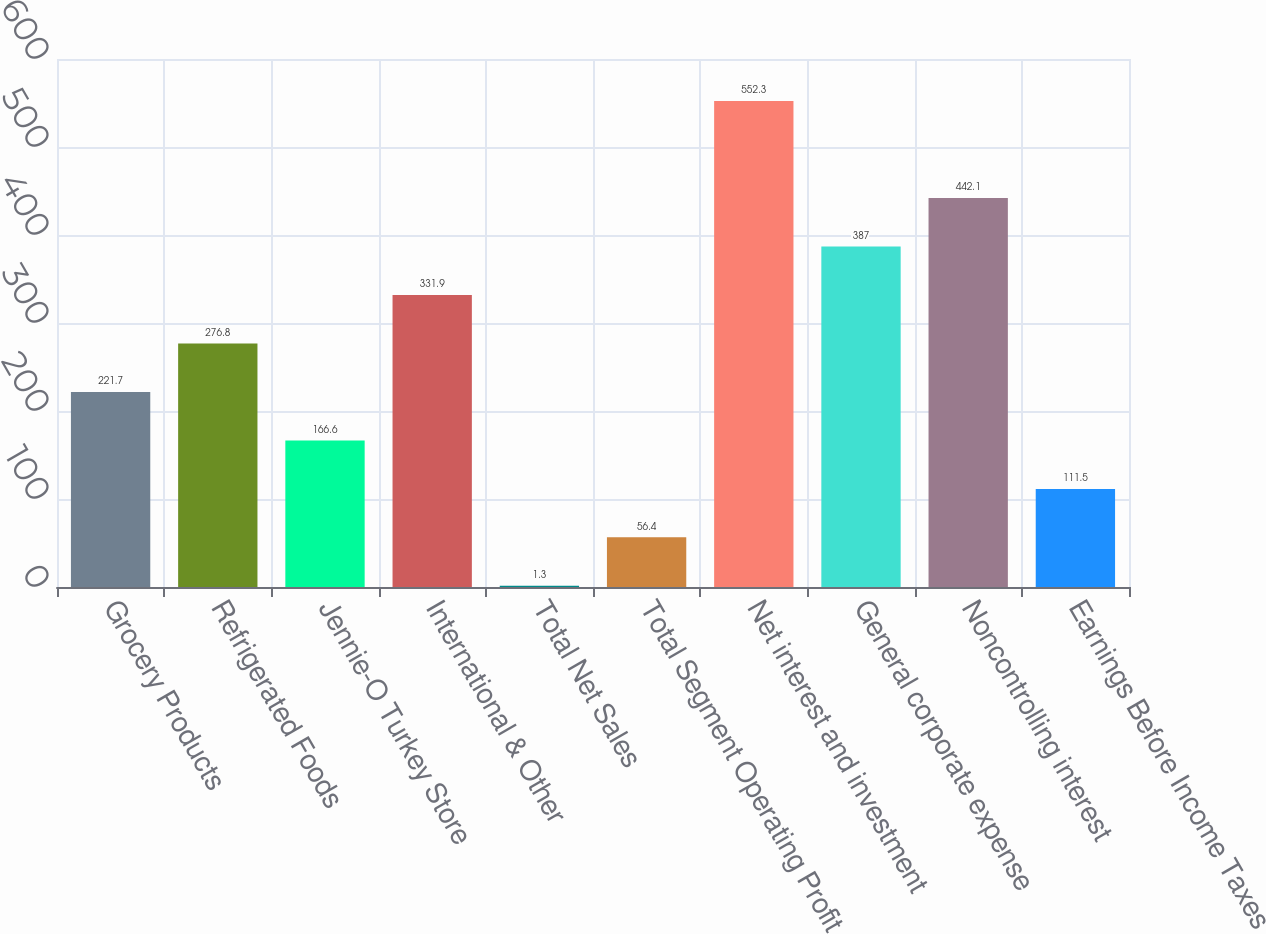Convert chart to OTSL. <chart><loc_0><loc_0><loc_500><loc_500><bar_chart><fcel>Grocery Products<fcel>Refrigerated Foods<fcel>Jennie-O Turkey Store<fcel>International & Other<fcel>Total Net Sales<fcel>Total Segment Operating Profit<fcel>Net interest and investment<fcel>General corporate expense<fcel>Noncontrolling interest<fcel>Earnings Before Income Taxes<nl><fcel>221.7<fcel>276.8<fcel>166.6<fcel>331.9<fcel>1.3<fcel>56.4<fcel>552.3<fcel>387<fcel>442.1<fcel>111.5<nl></chart> 